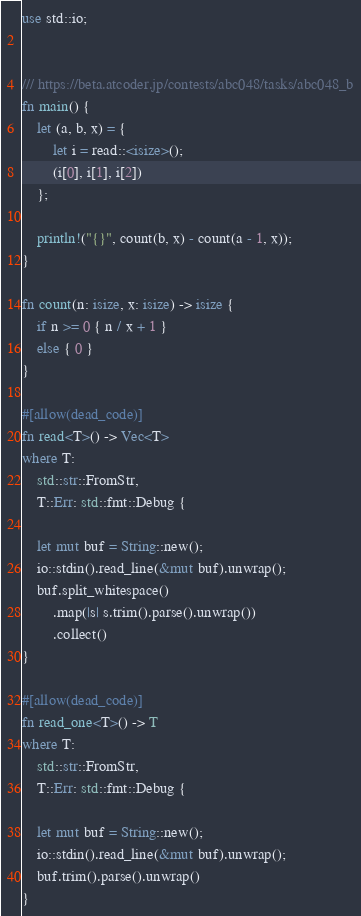Convert code to text. <code><loc_0><loc_0><loc_500><loc_500><_Rust_>use std::io;


/// https://beta.atcoder.jp/contests/abc048/tasks/abc048_b
fn main() {
    let (a, b, x) = {
        let i = read::<isize>();
        (i[0], i[1], i[2])
    };

    println!("{}", count(b, x) - count(a - 1, x));
}

fn count(n: isize, x: isize) -> isize {
    if n >= 0 { n / x + 1 }
    else { 0 }
}

#[allow(dead_code)]
fn read<T>() -> Vec<T>
where T:
    std::str::FromStr,
    T::Err: std::fmt::Debug {

    let mut buf = String::new();
    io::stdin().read_line(&mut buf).unwrap();
    buf.split_whitespace()
        .map(|s| s.trim().parse().unwrap())
        .collect()
}

#[allow(dead_code)]
fn read_one<T>() -> T
where T:
    std::str::FromStr,
    T::Err: std::fmt::Debug {

    let mut buf = String::new();
    io::stdin().read_line(&mut buf).unwrap();
    buf.trim().parse().unwrap()
}</code> 